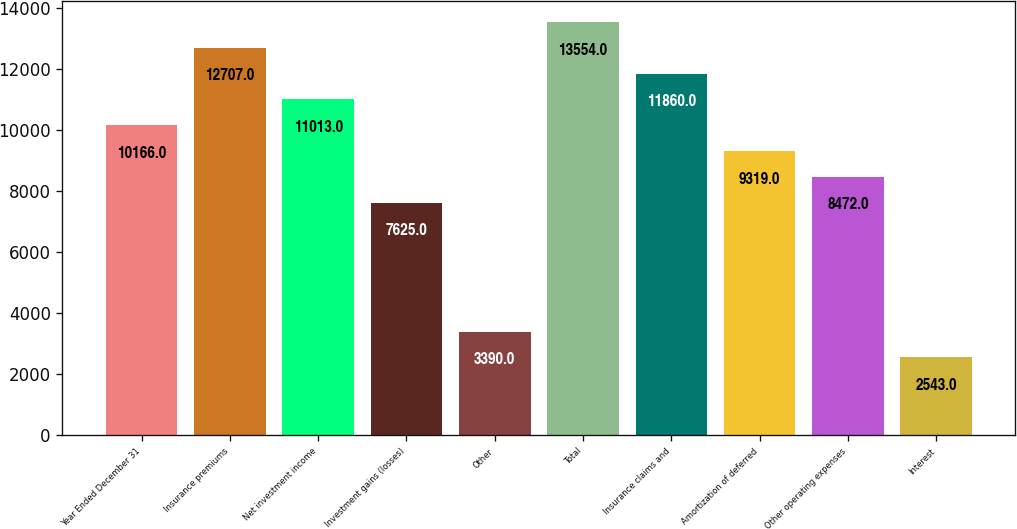Convert chart. <chart><loc_0><loc_0><loc_500><loc_500><bar_chart><fcel>Year Ended December 31<fcel>Insurance premiums<fcel>Net investment income<fcel>Investment gains (losses)<fcel>Other<fcel>Total<fcel>Insurance claims and<fcel>Amortization of deferred<fcel>Other operating expenses<fcel>Interest<nl><fcel>10166<fcel>12707<fcel>11013<fcel>7625<fcel>3390<fcel>13554<fcel>11860<fcel>9319<fcel>8472<fcel>2543<nl></chart> 